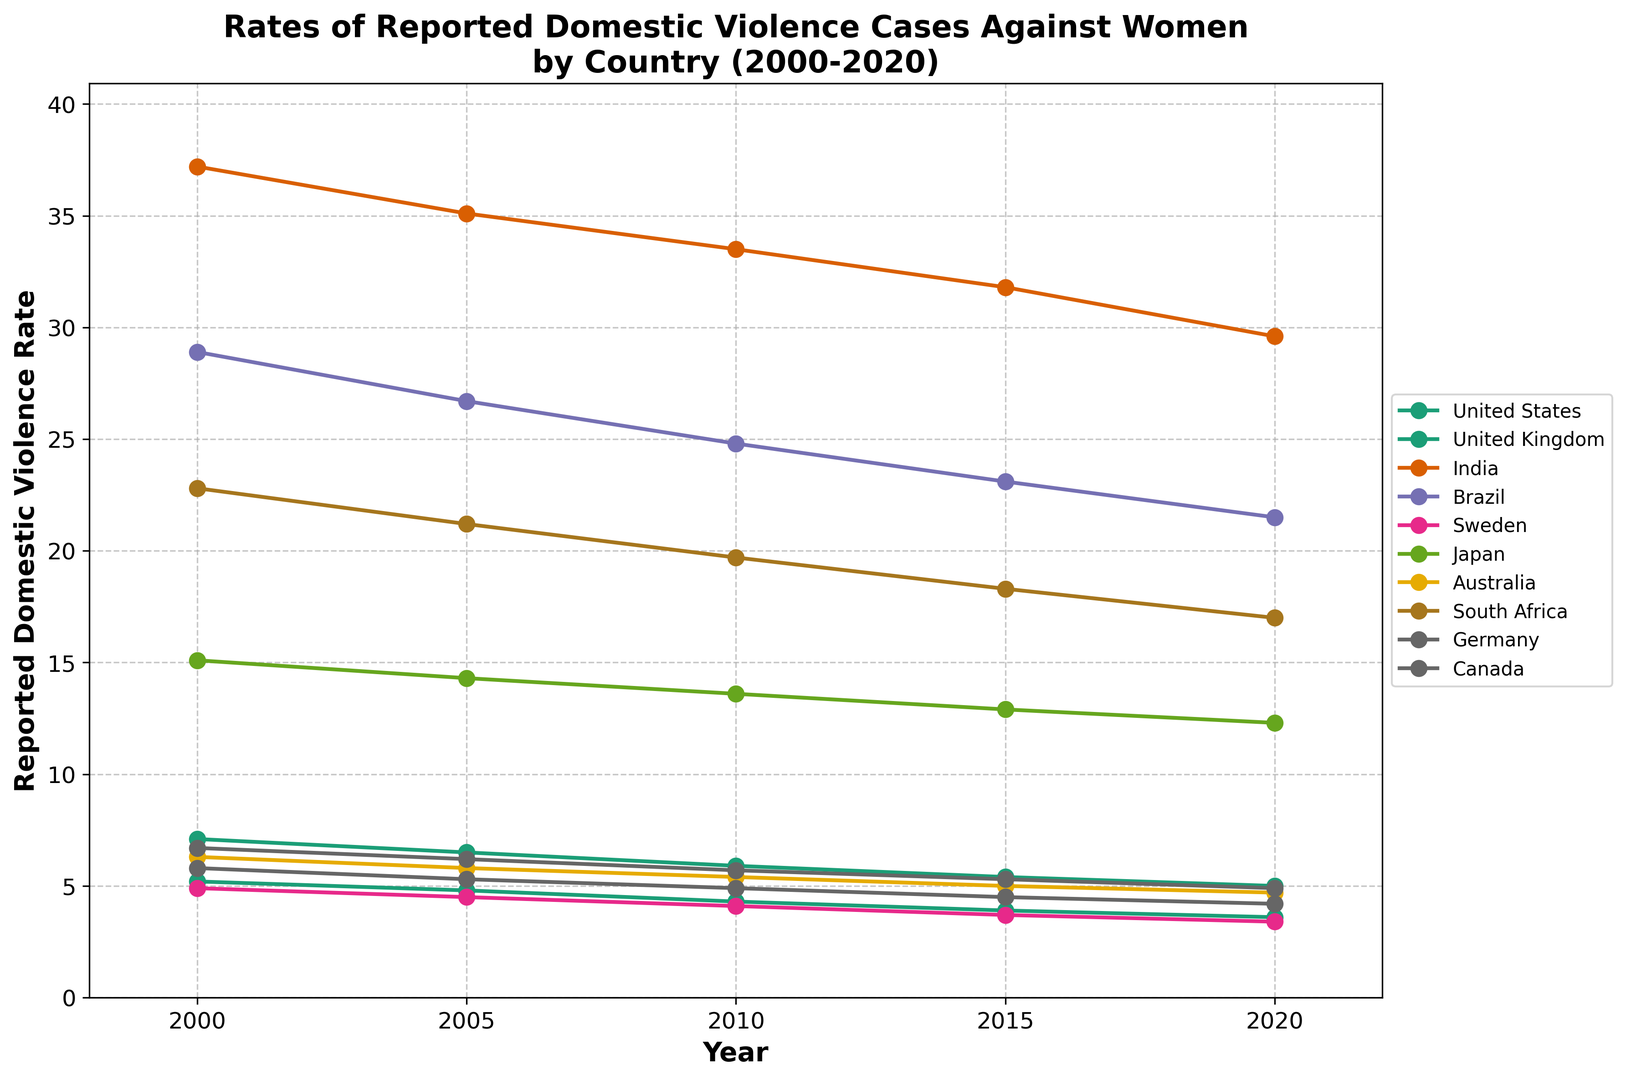Which country has the highest rate of reported domestic violence cases in 2000? Inspect the data points corresponding to the year 2000 for each country. India has the highest rate at 37.2.
Answer: India How has the rate of reported domestic violence cases changed in the United States from 2000 to 2020? Observe the trend line for the United States from 2000 to 2020. It shows a decrease from 5.2 to 3.6.
Answer: Decreased Which country had a higher rate of reported domestic violence cases in 2010, Brazil or South Africa? Look at the data points for 2010 for both Brazil and South Africa. Brazil has 24.8 and South Africa has 19.7.
Answer: Brazil Compare the rate of reported domestic violence cases between Japan and Germany in 2020. Which country had a higher rate? Check the data points for 2020 for both Japan and Germany. Japan has a rate of 12.3, and Germany has 4.9.
Answer: Japan Which country experienced the largest absolute decrease in the rate of reported domestic violence from 2000 to 2020? Calculate the decrease for each country by subtracting the rate in 2020 from the rate in 2000. India shows the largest decrease: 37.2 - 29.6 = 7.6.
Answer: India What is the average rate of reported domestic violence cases in Australia over the years 2000 to 2020? Sum the rates for Australia from 2000 to 2020: 6.3 + 5.8 + 5.4 + 5.0 + 4.7 = 27.2. Divide by 5: 27.2 / 5 = 5.44.
Answer: 5.44 Between 2005 and 2015, which country showed the smallest change in the rate of reported domestic violence cases? Calculate the difference between the rates of 2005 and 2015 for each country, then look for the smallest absolute value. Germany's change is the smallest: 6.2 - 5.3 = 0.9.
Answer: Germany Which country shows a consistent decrease in the rate of reported domestic violence cases across all observed years? Observe the trend lines for consistency in decrease from 2000 to 2020. All countries show a decline, but the United States has a steady and consistent decrease across all years.
Answer: United States What is the difference in the rate of reported domestic violence cases between India and Sweden in 2020? Subtract the 2020 rate of Sweden from the 2020 rate of India: 29.6 - 3.4 = 26.2.
Answer: 26.2 Which country had a rate closest to 5 in the year 2020? Look at the 2020 data points and identify which rate is closest to 5. The United Kingdom has a rate of 5.0.
Answer: United Kingdom 